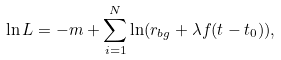Convert formula to latex. <formula><loc_0><loc_0><loc_500><loc_500>\ln L = - m + \sum _ { i = 1 } ^ { N } \ln ( r _ { b g } + \lambda f ( t - t _ { 0 } ) ) ,</formula> 